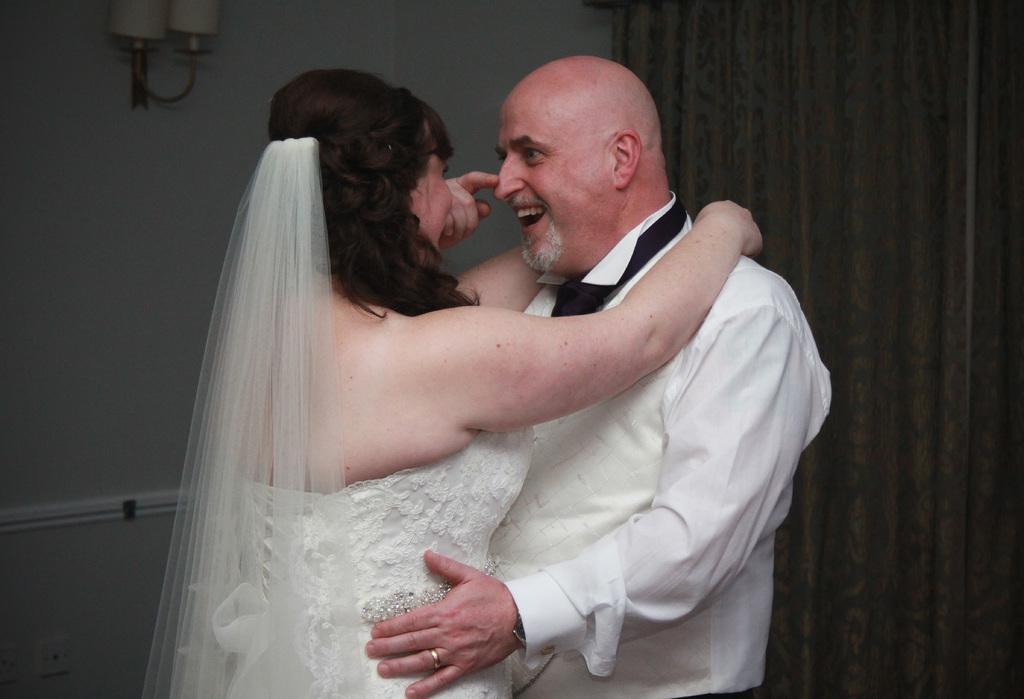Could you give a brief overview of what you see in this image? In the center of the image we can see two persons are standing and they are smiling, which we can see on their faces. And the woman is in white color dress. In the background there is a wall, lamp, curtain and a few other objects. 